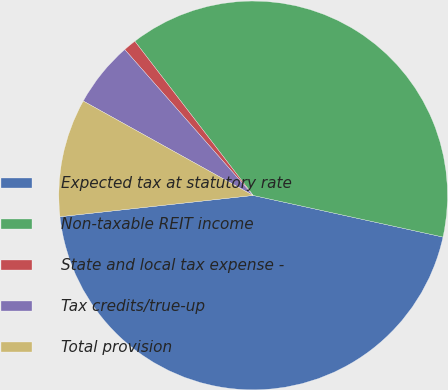Convert chart to OTSL. <chart><loc_0><loc_0><loc_500><loc_500><pie_chart><fcel>Expected tax at statutory rate<fcel>Non-taxable REIT income<fcel>State and local tax expense -<fcel>Tax credits/true-up<fcel>Total provision<nl><fcel>44.82%<fcel>38.85%<fcel>1.07%<fcel>5.44%<fcel>9.82%<nl></chart> 